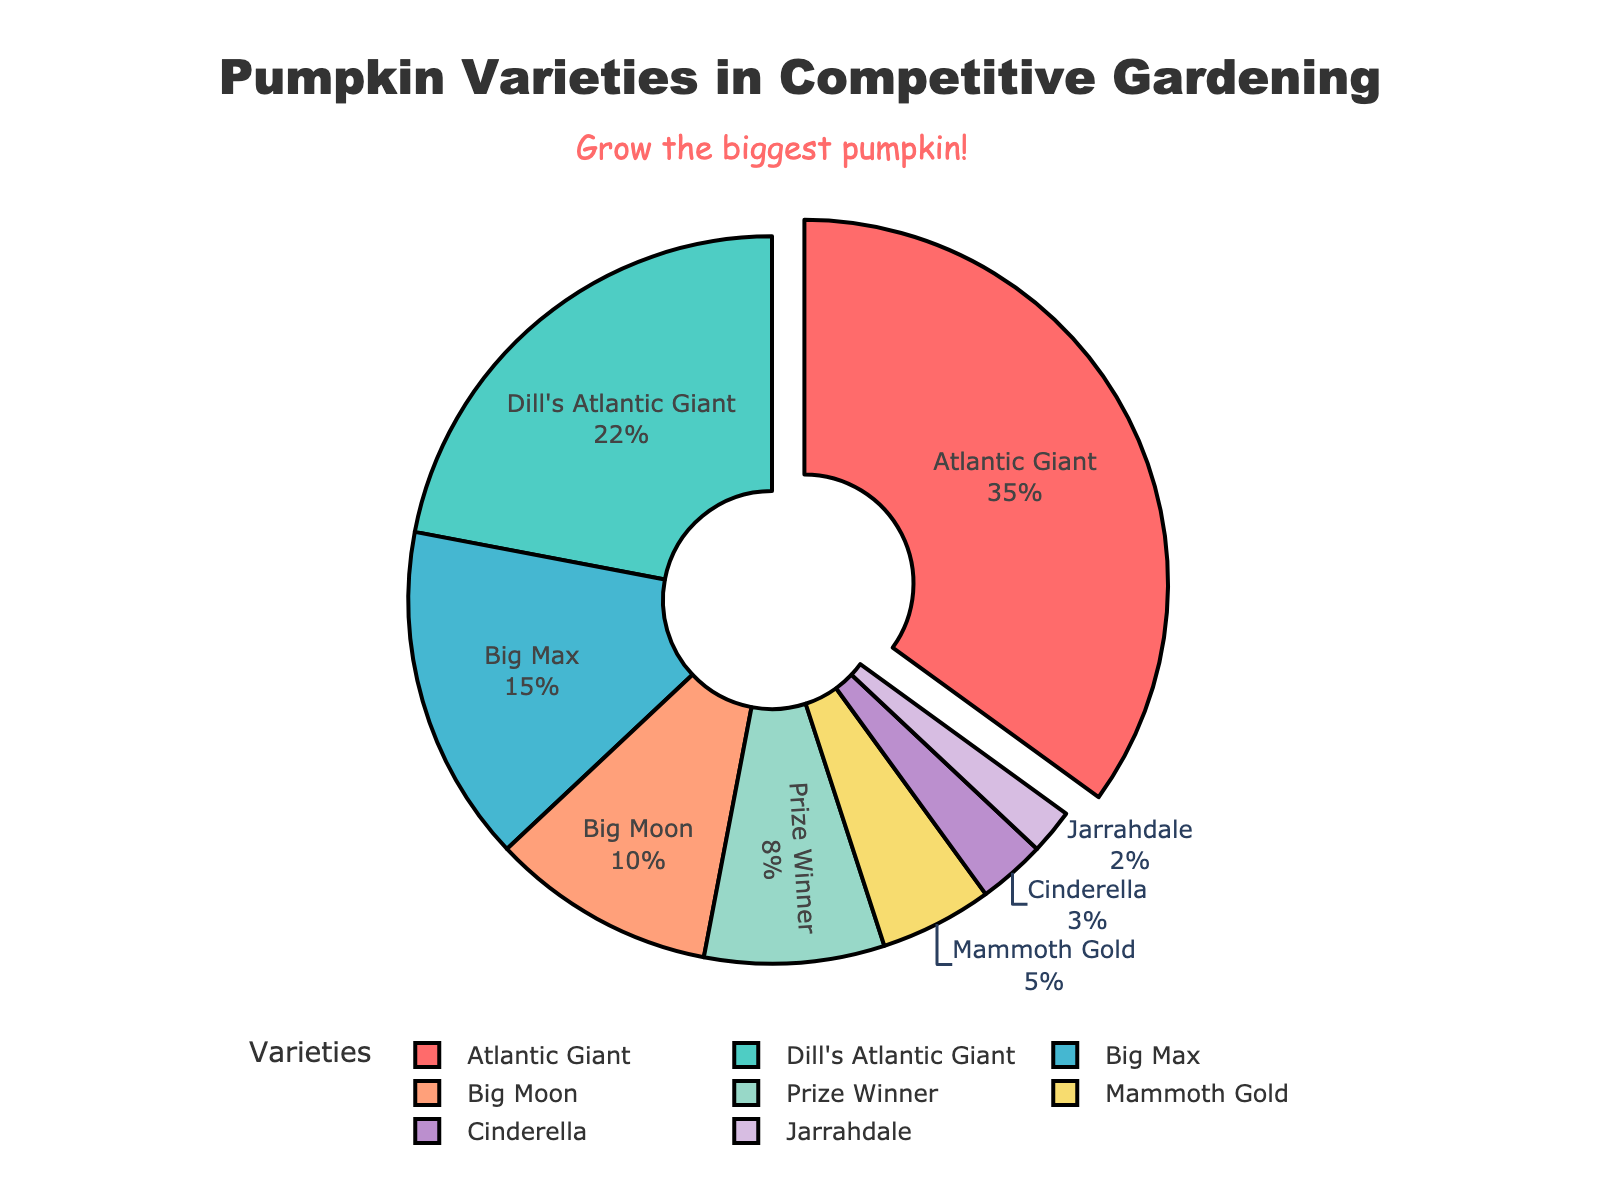What percentage of pumpkin varieties is accounted for by Atlantic Giant and Big Moon combined? Add the percentage of Atlantic Giant (35%) and Big Moon (10%). So, 35 + 10 = 45%
Answer: 45% Which variety has the highest percentage? The pie chart shows the variety with the largest slice and label text indicating the highest percentage. Here, it is Atlantic Giant with 35%.
Answer: Atlantic Giant What is the difference in percentage between Dill's Atlantic Giant and Mammoth Gold? Subtract the percentage of Mammoth Gold (5%) from Dill's Atlantic Giant (22%). So, 22 - 5 = 17%
Answer: 17% Which variety occupies the smallest percentage? The pie chart shows the smallest slice with the label "Jarrahdale" indicating 2%, which is the smallest percentage.
Answer: Jarrahdale Are there more Cinderella or Prize Winner pumpkins, and by how much? Compare the percentages: Prize Winner has 8% while Cinderella has 3%. The difference is 8 - 3 = 5%.
Answer: Prize Winner by 5% What percentage of the varieties consists of Big Max and Prize Winner together? Add the percentages of Big Max (15%) and Prize Winner (8%). So, 15 + 8 = 23%
Answer: 23% How much more is the percentage of Big Max compared to Cinderella? Subtract the percentage of Cinderella (3%) from Big Max (15%). So, 15 - 3 = 12%
Answer: 12% Which slice is colored red and what variety does it represent? The pie chart's legend shows that the slice colored red represents the "Atlantic Giant" variety.
Answer: Atlantic Giant Do Atlantic Giant and Dill's Atlantic Giant combined make up more than half of the pie chart? Add the percentages of Atlantic Giant (35%) and Dill's Atlantic Giant (22%). So, 35 + 22 = 57%. Then compare to 50%.
Answer: Yes, 57% What is the second most common pumpkin variety in this distribution? The pie chart shows that Dill's Atlantic Giant, with 22%, is the second-largest slice.
Answer: Dill's Atlantic Giant 